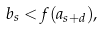Convert formula to latex. <formula><loc_0><loc_0><loc_500><loc_500>b _ { s } < f ( a _ { s + d } ) ,</formula> 